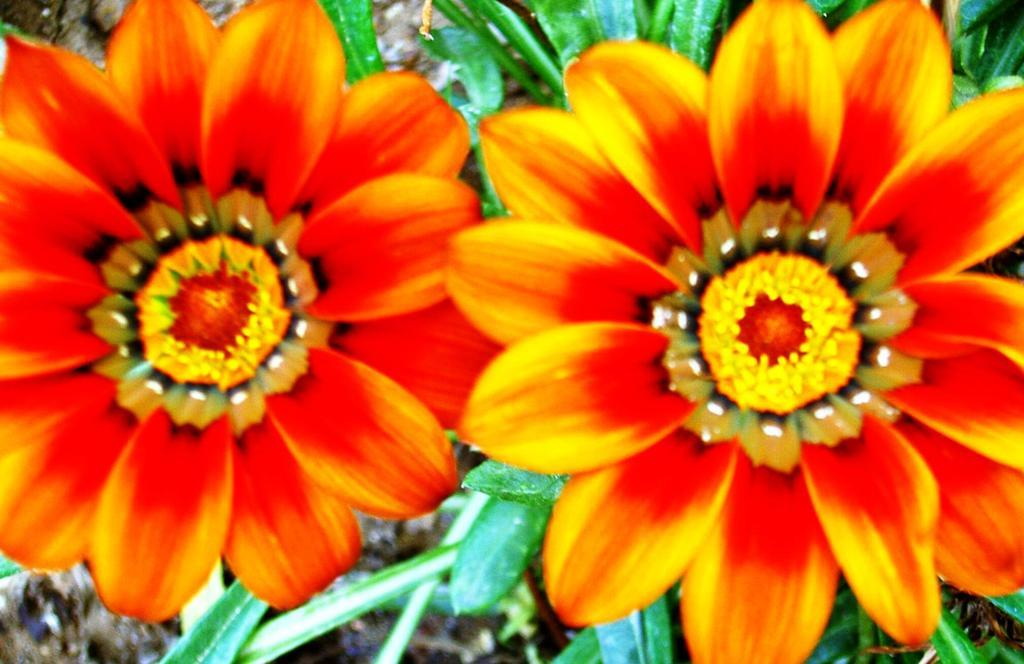What is the main subject of the image? The main subject of the image is a zoomed in picture of flowers. Can you describe any other elements visible in the image? Yes, there are leaves visible in the background of the image. What type of chain can be seen connecting the flowers in the image? There is no chain present in the image; it is a picture of flowers and leaves. 